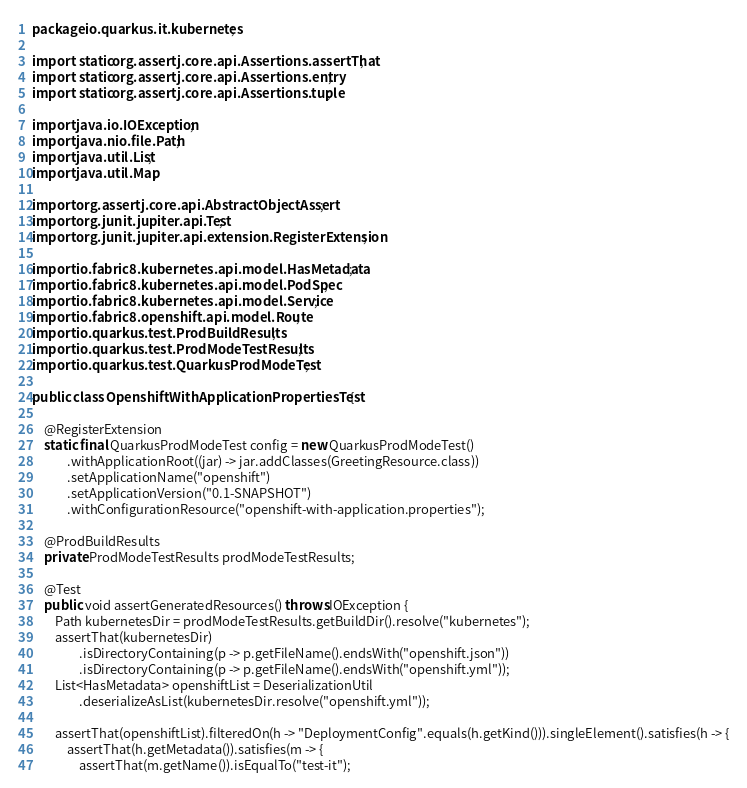<code> <loc_0><loc_0><loc_500><loc_500><_Java_>package io.quarkus.it.kubernetes;

import static org.assertj.core.api.Assertions.assertThat;
import static org.assertj.core.api.Assertions.entry;
import static org.assertj.core.api.Assertions.tuple;

import java.io.IOException;
import java.nio.file.Path;
import java.util.List;
import java.util.Map;

import org.assertj.core.api.AbstractObjectAssert;
import org.junit.jupiter.api.Test;
import org.junit.jupiter.api.extension.RegisterExtension;

import io.fabric8.kubernetes.api.model.HasMetadata;
import io.fabric8.kubernetes.api.model.PodSpec;
import io.fabric8.kubernetes.api.model.Service;
import io.fabric8.openshift.api.model.Route;
import io.quarkus.test.ProdBuildResults;
import io.quarkus.test.ProdModeTestResults;
import io.quarkus.test.QuarkusProdModeTest;

public class OpenshiftWithApplicationPropertiesTest {

    @RegisterExtension
    static final QuarkusProdModeTest config = new QuarkusProdModeTest()
            .withApplicationRoot((jar) -> jar.addClasses(GreetingResource.class))
            .setApplicationName("openshift")
            .setApplicationVersion("0.1-SNAPSHOT")
            .withConfigurationResource("openshift-with-application.properties");

    @ProdBuildResults
    private ProdModeTestResults prodModeTestResults;

    @Test
    public void assertGeneratedResources() throws IOException {
        Path kubernetesDir = prodModeTestResults.getBuildDir().resolve("kubernetes");
        assertThat(kubernetesDir)
                .isDirectoryContaining(p -> p.getFileName().endsWith("openshift.json"))
                .isDirectoryContaining(p -> p.getFileName().endsWith("openshift.yml"));
        List<HasMetadata> openshiftList = DeserializationUtil
                .deserializeAsList(kubernetesDir.resolve("openshift.yml"));

        assertThat(openshiftList).filteredOn(h -> "DeploymentConfig".equals(h.getKind())).singleElement().satisfies(h -> {
            assertThat(h.getMetadata()).satisfies(m -> {
                assertThat(m.getName()).isEqualTo("test-it");</code> 